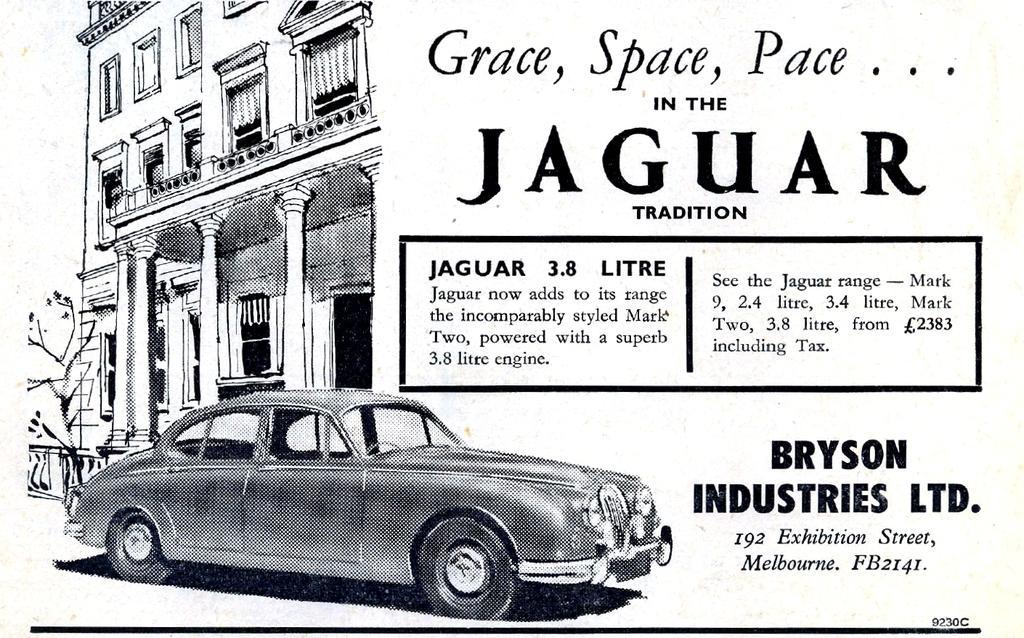How would you summarize this image in a sentence or two? This image is a poster. There is a depiction of a car, building. There is text. 